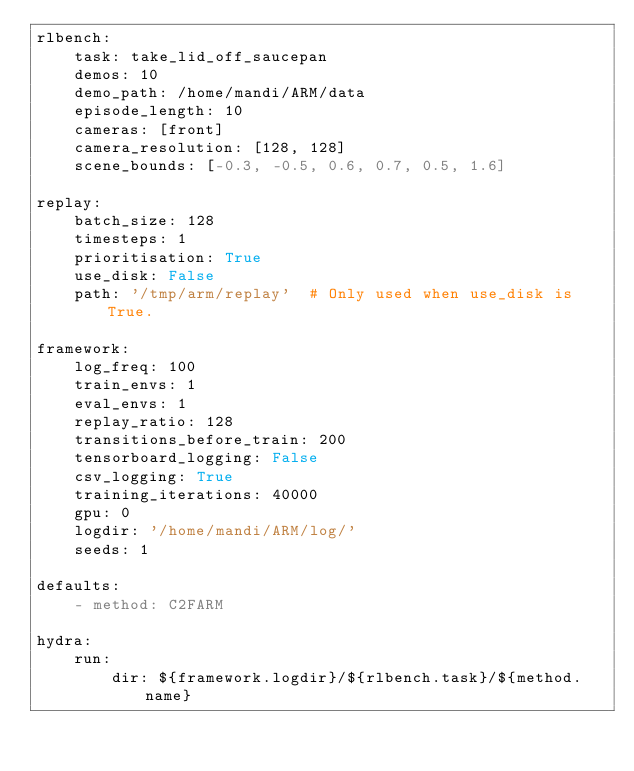<code> <loc_0><loc_0><loc_500><loc_500><_YAML_>rlbench:
    task: take_lid_off_saucepan
    demos: 10
    demo_path: /home/mandi/ARM/data
    episode_length: 10
    cameras: [front]
    camera_resolution: [128, 128]
    scene_bounds: [-0.3, -0.5, 0.6, 0.7, 0.5, 1.6]

replay:
    batch_size: 128
    timesteps: 1
    prioritisation: True
    use_disk: False
    path: '/tmp/arm/replay'  # Only used when use_disk is True.

framework:
    log_freq: 100
    train_envs: 1
    eval_envs: 1
    replay_ratio: 128
    transitions_before_train: 200
    tensorboard_logging: False
    csv_logging: True
    training_iterations: 40000
    gpu: 0
    logdir: '/home/mandi/ARM/log/'
    seeds: 1

defaults:
    - method: C2FARM

hydra:
    run:
        dir: ${framework.logdir}/${rlbench.task}/${method.name}</code> 